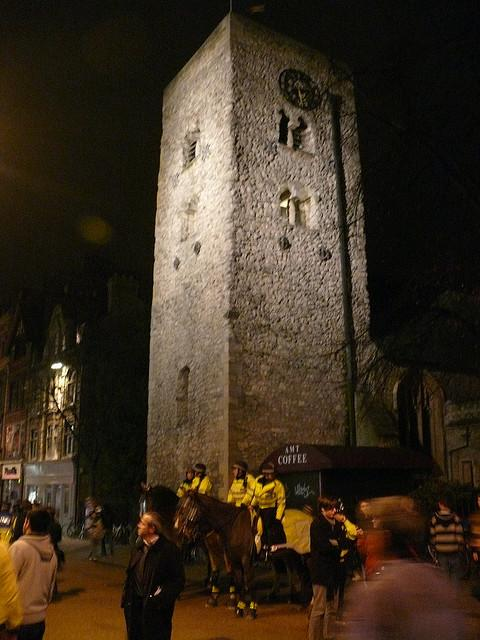What material composes this old square tower? stone 